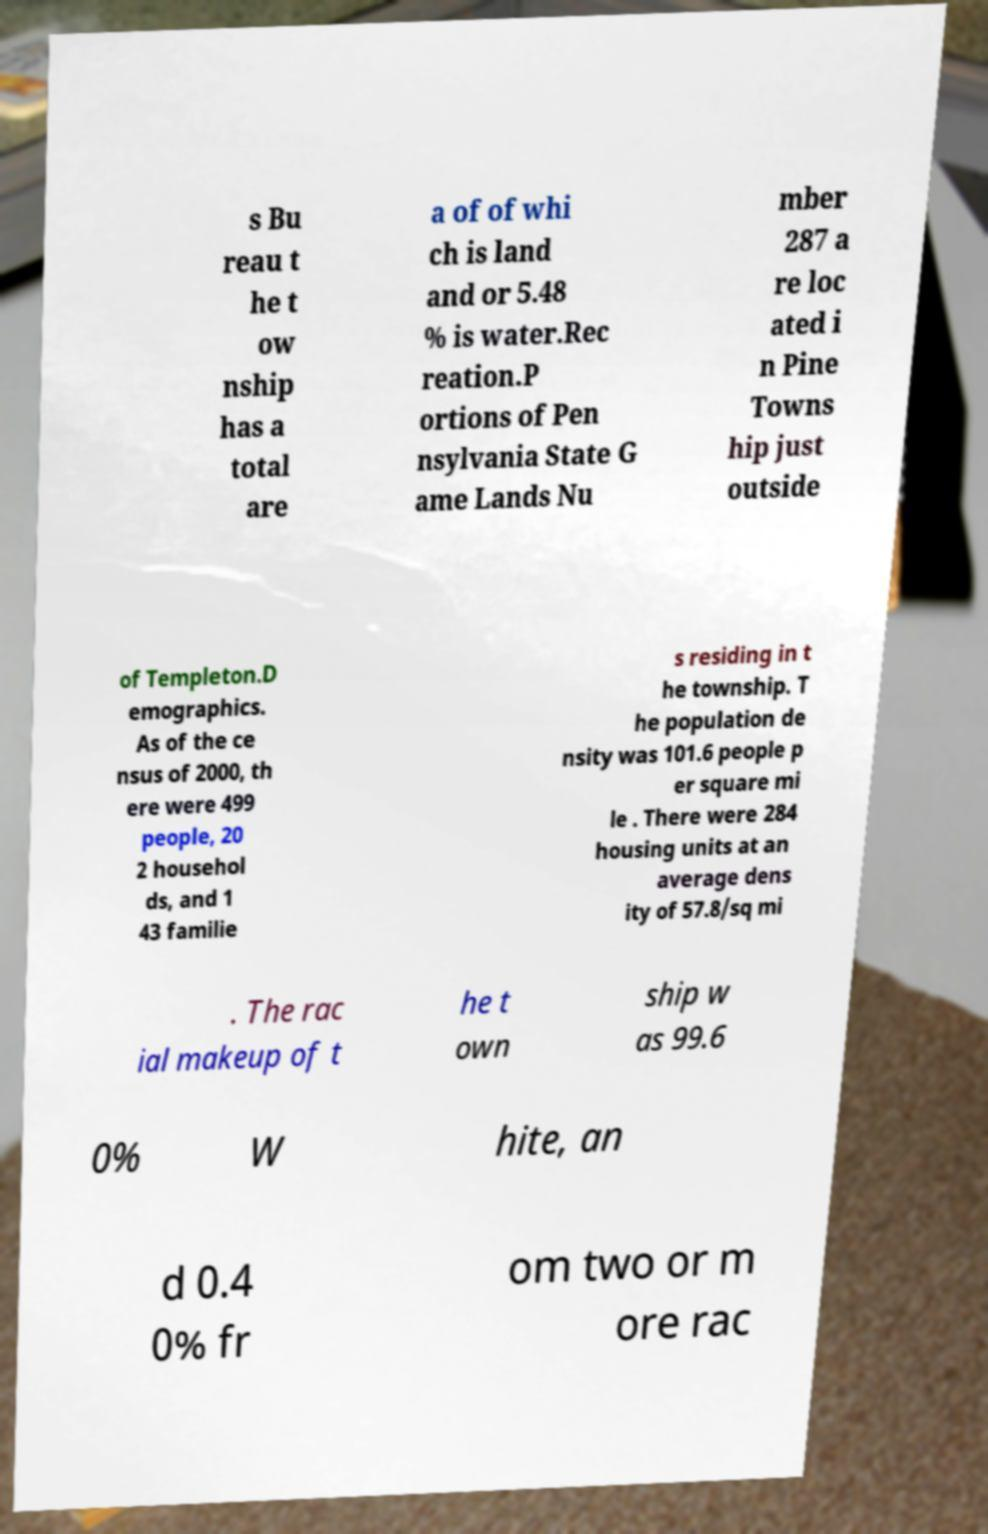Please identify and transcribe the text found in this image. s Bu reau t he t ow nship has a total are a of of whi ch is land and or 5.48 % is water.Rec reation.P ortions of Pen nsylvania State G ame Lands Nu mber 287 a re loc ated i n Pine Towns hip just outside of Templeton.D emographics. As of the ce nsus of 2000, th ere were 499 people, 20 2 househol ds, and 1 43 familie s residing in t he township. T he population de nsity was 101.6 people p er square mi le . There were 284 housing units at an average dens ity of 57.8/sq mi . The rac ial makeup of t he t own ship w as 99.6 0% W hite, an d 0.4 0% fr om two or m ore rac 